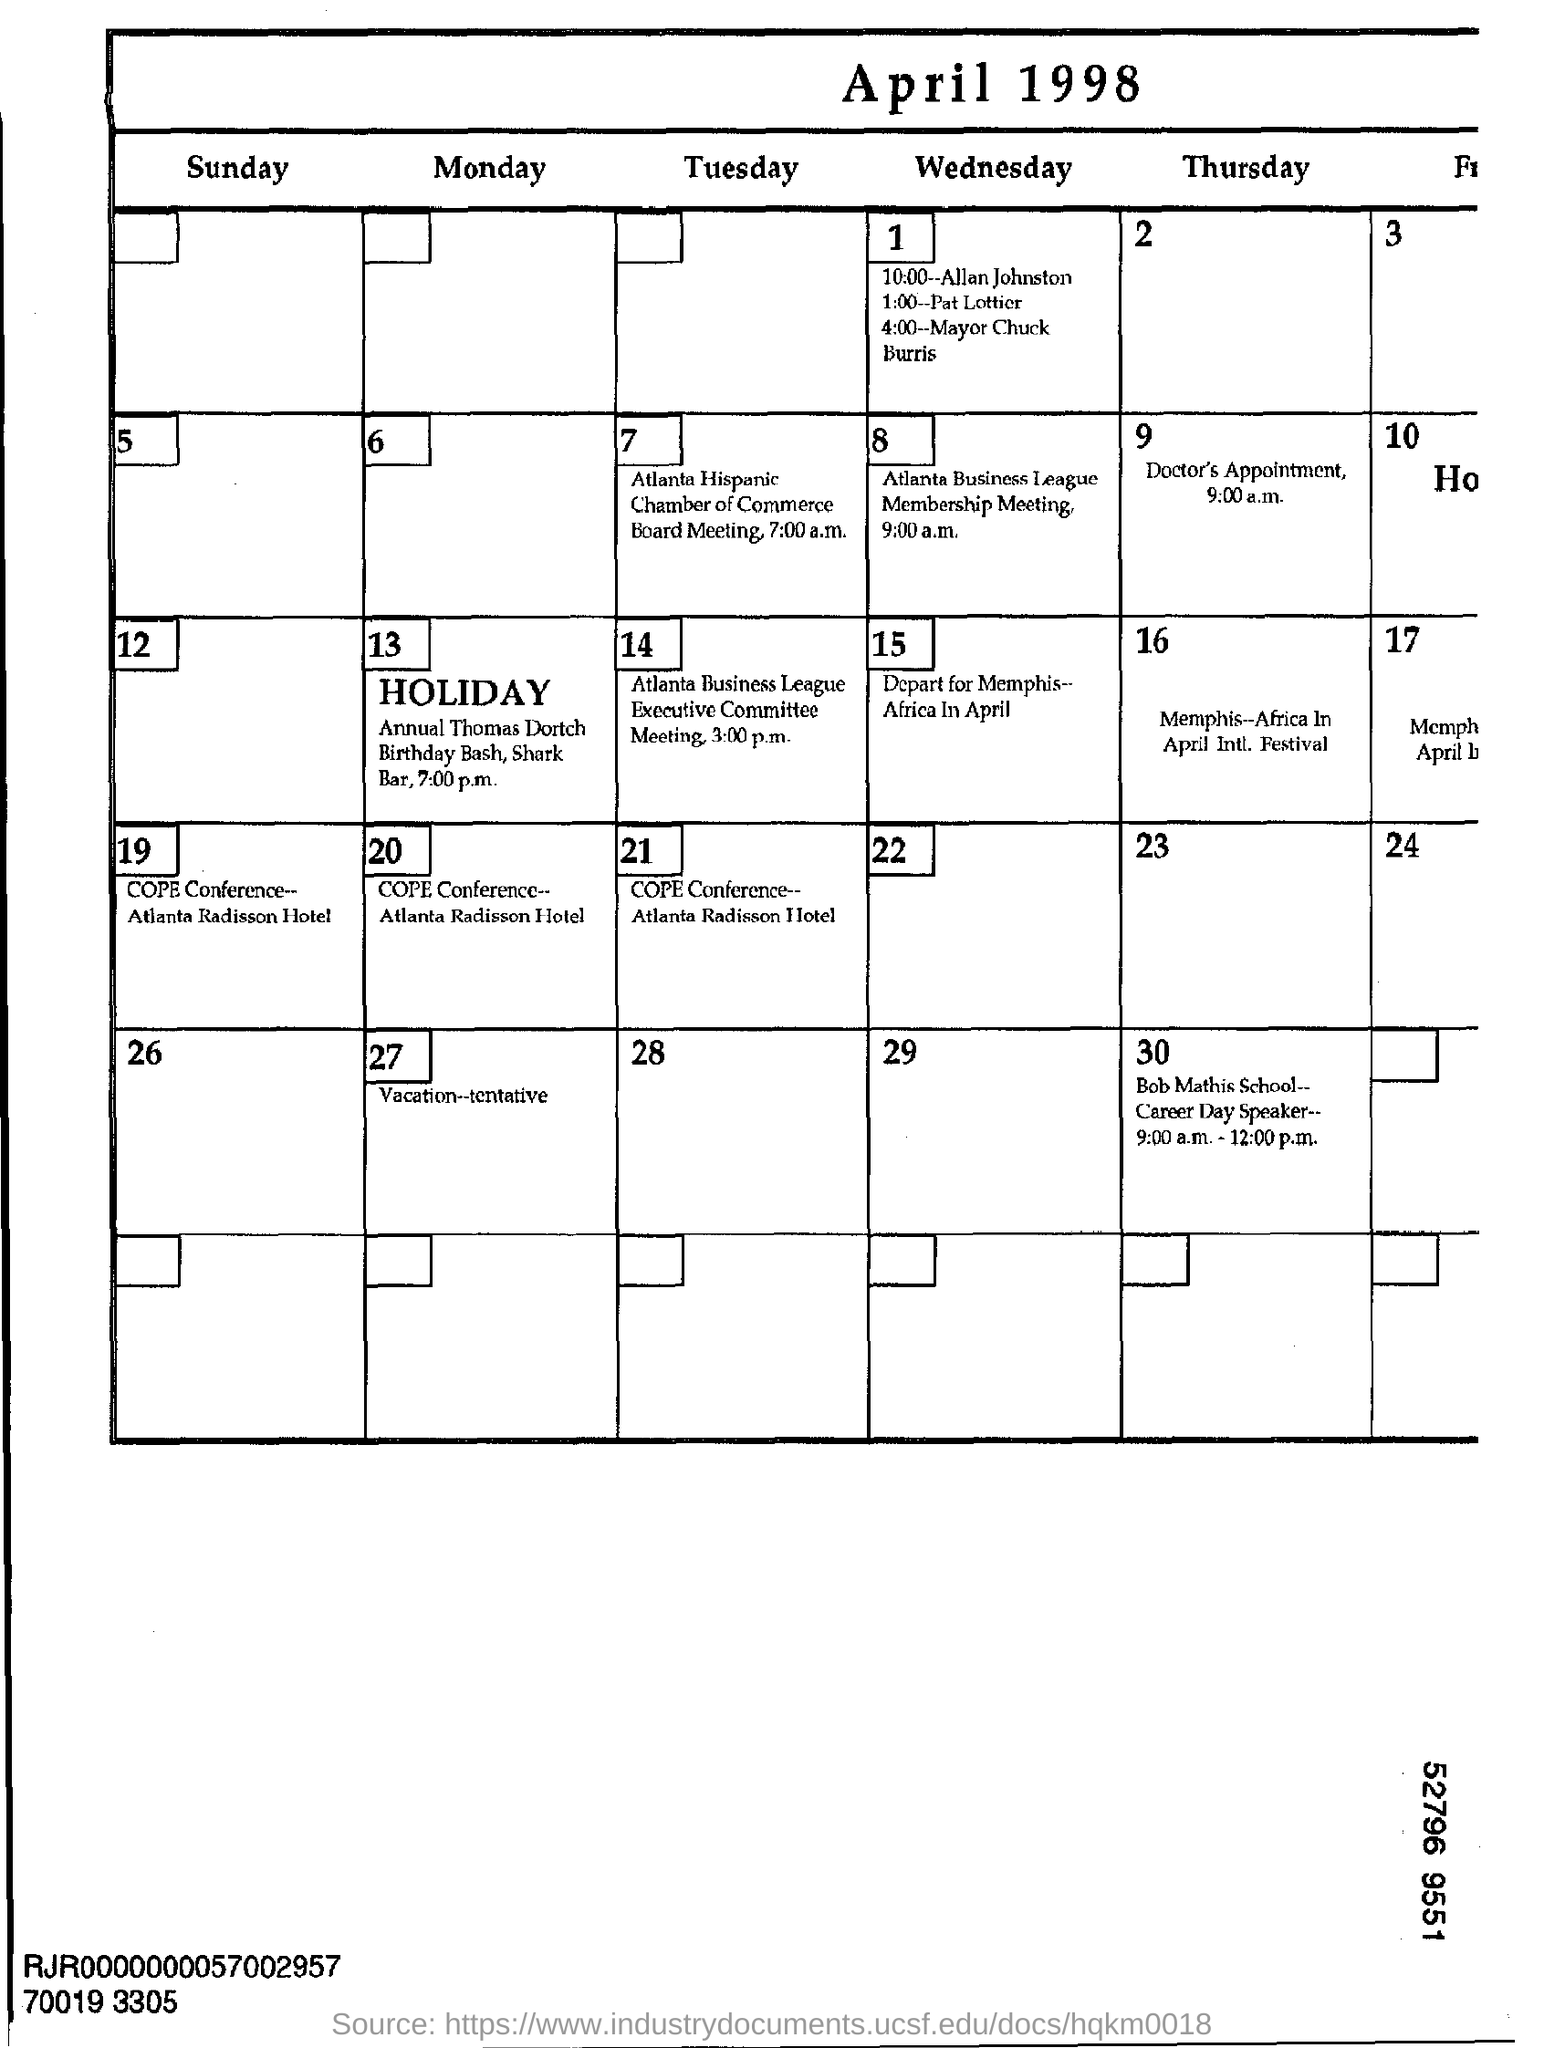What is the timing of Atlanta Business League Membership meeting?
Offer a very short reply. 9:00 a.m. What is the timing of Atlanta Hispanic Chamber of Commerce Board meeting?
Your answer should be compact. 7:00 a.m. What time is Atlanta Business League Membership meeting?
Provide a succinct answer. 9:00 a.m. What time is Atlanta Hispanic Chamber of Commerce Board meeting?
Make the answer very short. 7:00 a.m. 